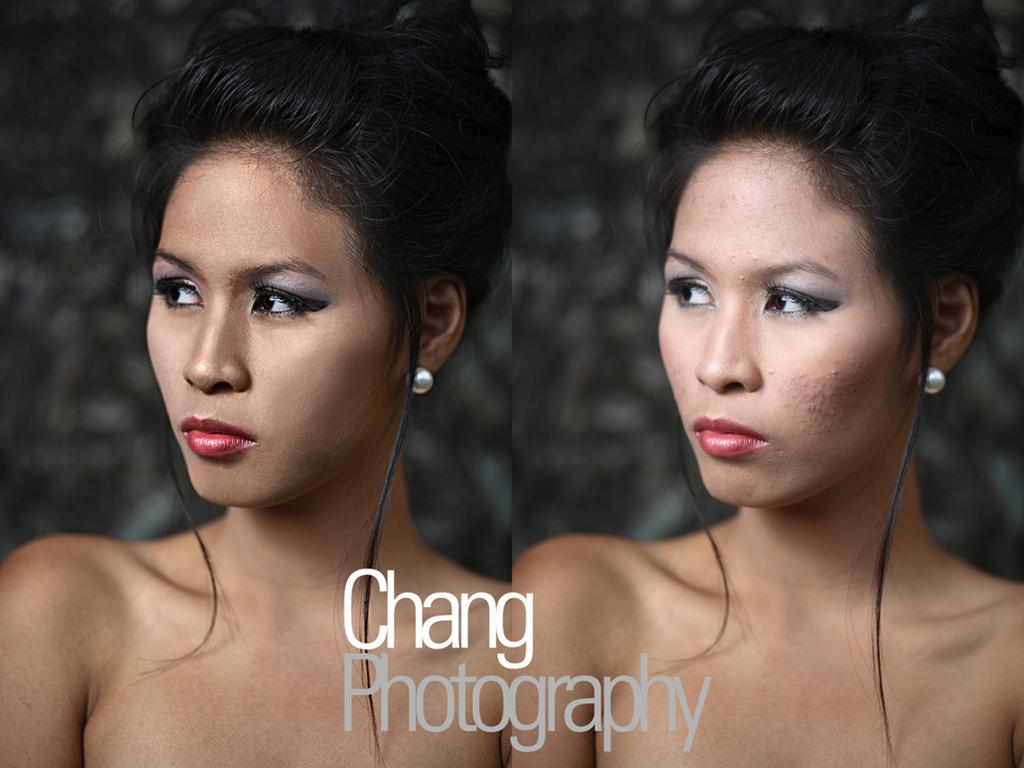What type of image is shown in the collage? The image is a collage of multiple pictures. Can you describe the subject of the pictures in the collage? There is a woman present in both pictures. Is there any text visible in the image? Yes, text is visible at the bottom of the image. What type of fan is visible in the image? There is no fan present in the image. What time of day is depicted in the image? The time of day is not specified in the image. 